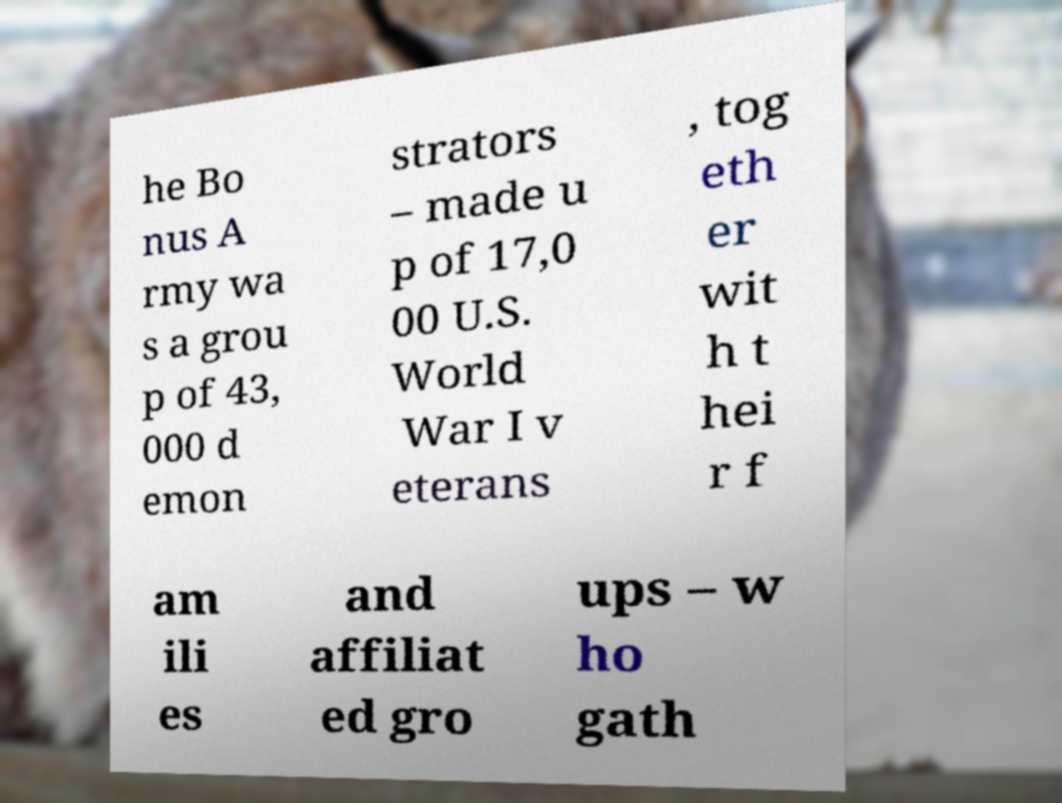Please identify and transcribe the text found in this image. he Bo nus A rmy wa s a grou p of 43, 000 d emon strators – made u p of 17,0 00 U.S. World War I v eterans , tog eth er wit h t hei r f am ili es and affiliat ed gro ups – w ho gath 